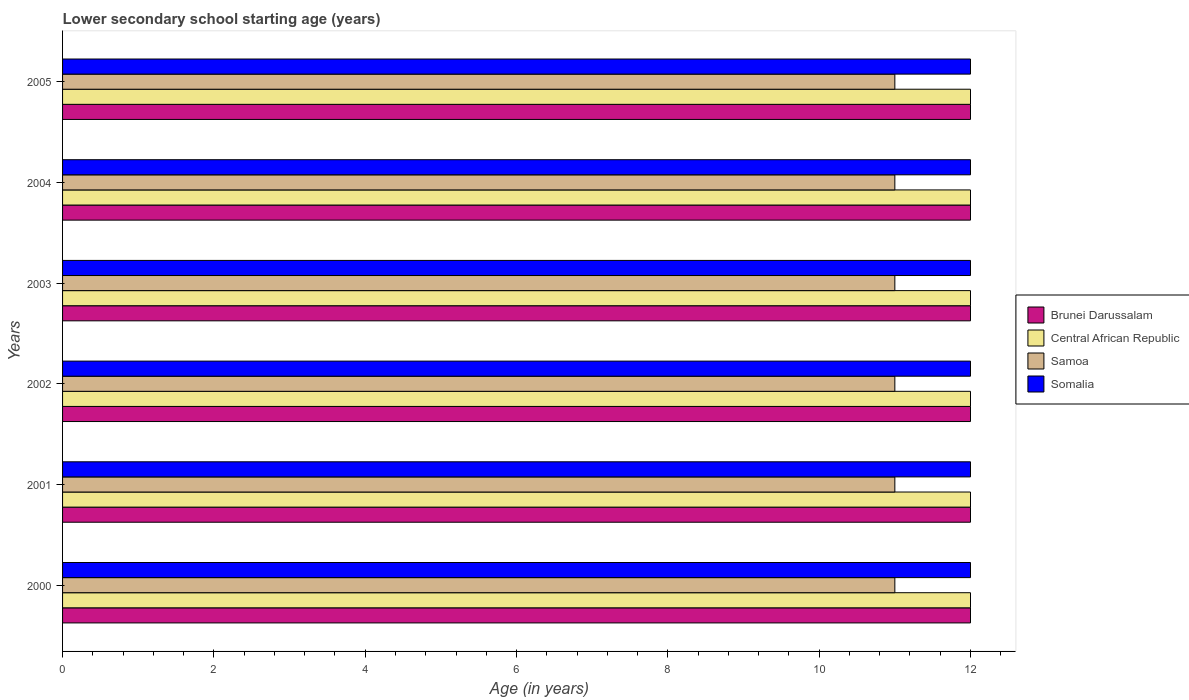How many different coloured bars are there?
Your response must be concise. 4. How many groups of bars are there?
Provide a succinct answer. 6. Are the number of bars per tick equal to the number of legend labels?
Give a very brief answer. Yes. Are the number of bars on each tick of the Y-axis equal?
Offer a very short reply. Yes. How many bars are there on the 1st tick from the top?
Ensure brevity in your answer.  4. How many bars are there on the 4th tick from the bottom?
Make the answer very short. 4. In how many cases, is the number of bars for a given year not equal to the number of legend labels?
Offer a very short reply. 0. What is the lower secondary school starting age of children in Central African Republic in 2005?
Ensure brevity in your answer.  12. Across all years, what is the maximum lower secondary school starting age of children in Samoa?
Offer a terse response. 11. Across all years, what is the minimum lower secondary school starting age of children in Brunei Darussalam?
Make the answer very short. 12. In which year was the lower secondary school starting age of children in Brunei Darussalam minimum?
Your answer should be very brief. 2000. What is the total lower secondary school starting age of children in Somalia in the graph?
Make the answer very short. 72. What is the average lower secondary school starting age of children in Samoa per year?
Make the answer very short. 11. What is the ratio of the lower secondary school starting age of children in Brunei Darussalam in 2002 to that in 2004?
Your response must be concise. 1. Is the difference between the lower secondary school starting age of children in Somalia in 2000 and 2002 greater than the difference between the lower secondary school starting age of children in Brunei Darussalam in 2000 and 2002?
Your response must be concise. No. In how many years, is the lower secondary school starting age of children in Central African Republic greater than the average lower secondary school starting age of children in Central African Republic taken over all years?
Keep it short and to the point. 0. Is the sum of the lower secondary school starting age of children in Somalia in 2003 and 2004 greater than the maximum lower secondary school starting age of children in Samoa across all years?
Offer a terse response. Yes. Is it the case that in every year, the sum of the lower secondary school starting age of children in Brunei Darussalam and lower secondary school starting age of children in Somalia is greater than the sum of lower secondary school starting age of children in Central African Republic and lower secondary school starting age of children in Samoa?
Your answer should be very brief. No. What does the 4th bar from the top in 2001 represents?
Your answer should be compact. Brunei Darussalam. What does the 2nd bar from the bottom in 2003 represents?
Your answer should be compact. Central African Republic. How many bars are there?
Your answer should be compact. 24. Are all the bars in the graph horizontal?
Your answer should be compact. Yes. Are the values on the major ticks of X-axis written in scientific E-notation?
Make the answer very short. No. Does the graph contain grids?
Your answer should be compact. No. Where does the legend appear in the graph?
Provide a short and direct response. Center right. How many legend labels are there?
Make the answer very short. 4. What is the title of the graph?
Ensure brevity in your answer.  Lower secondary school starting age (years). What is the label or title of the X-axis?
Ensure brevity in your answer.  Age (in years). What is the Age (in years) in Central African Republic in 2001?
Ensure brevity in your answer.  12. What is the Age (in years) of Central African Republic in 2002?
Provide a succinct answer. 12. What is the Age (in years) of Somalia in 2002?
Offer a very short reply. 12. What is the Age (in years) of Central African Republic in 2003?
Make the answer very short. 12. What is the Age (in years) of Somalia in 2003?
Provide a succinct answer. 12. What is the Age (in years) in Brunei Darussalam in 2004?
Provide a short and direct response. 12. What is the Age (in years) in Central African Republic in 2004?
Ensure brevity in your answer.  12. What is the Age (in years) in Samoa in 2004?
Your answer should be very brief. 11. What is the Age (in years) of Brunei Darussalam in 2005?
Provide a short and direct response. 12. What is the Age (in years) in Central African Republic in 2005?
Offer a terse response. 12. What is the Age (in years) in Samoa in 2005?
Your answer should be compact. 11. Across all years, what is the maximum Age (in years) in Brunei Darussalam?
Provide a succinct answer. 12. Across all years, what is the minimum Age (in years) of Central African Republic?
Provide a succinct answer. 12. What is the total Age (in years) of Samoa in the graph?
Make the answer very short. 66. What is the total Age (in years) of Somalia in the graph?
Make the answer very short. 72. What is the difference between the Age (in years) of Brunei Darussalam in 2000 and that in 2001?
Offer a terse response. 0. What is the difference between the Age (in years) of Central African Republic in 2000 and that in 2001?
Offer a very short reply. 0. What is the difference between the Age (in years) of Brunei Darussalam in 2000 and that in 2002?
Keep it short and to the point. 0. What is the difference between the Age (in years) of Central African Republic in 2000 and that in 2002?
Offer a terse response. 0. What is the difference between the Age (in years) of Samoa in 2000 and that in 2002?
Provide a short and direct response. 0. What is the difference between the Age (in years) in Brunei Darussalam in 2000 and that in 2003?
Provide a succinct answer. 0. What is the difference between the Age (in years) of Central African Republic in 2000 and that in 2003?
Offer a very short reply. 0. What is the difference between the Age (in years) of Somalia in 2000 and that in 2003?
Your answer should be very brief. 0. What is the difference between the Age (in years) in Brunei Darussalam in 2000 and that in 2004?
Keep it short and to the point. 0. What is the difference between the Age (in years) of Brunei Darussalam in 2000 and that in 2005?
Your response must be concise. 0. What is the difference between the Age (in years) of Samoa in 2000 and that in 2005?
Your answer should be compact. 0. What is the difference between the Age (in years) in Somalia in 2000 and that in 2005?
Ensure brevity in your answer.  0. What is the difference between the Age (in years) in Samoa in 2001 and that in 2002?
Keep it short and to the point. 0. What is the difference between the Age (in years) in Central African Republic in 2001 and that in 2003?
Your answer should be compact. 0. What is the difference between the Age (in years) of Samoa in 2001 and that in 2003?
Provide a succinct answer. 0. What is the difference between the Age (in years) in Somalia in 2001 and that in 2003?
Provide a succinct answer. 0. What is the difference between the Age (in years) in Brunei Darussalam in 2001 and that in 2004?
Your response must be concise. 0. What is the difference between the Age (in years) in Central African Republic in 2001 and that in 2004?
Give a very brief answer. 0. What is the difference between the Age (in years) of Samoa in 2001 and that in 2004?
Offer a very short reply. 0. What is the difference between the Age (in years) in Somalia in 2001 and that in 2004?
Your answer should be compact. 0. What is the difference between the Age (in years) of Central African Republic in 2001 and that in 2005?
Provide a short and direct response. 0. What is the difference between the Age (in years) of Samoa in 2001 and that in 2005?
Keep it short and to the point. 0. What is the difference between the Age (in years) in Somalia in 2001 and that in 2005?
Provide a short and direct response. 0. What is the difference between the Age (in years) of Brunei Darussalam in 2002 and that in 2003?
Your answer should be very brief. 0. What is the difference between the Age (in years) in Samoa in 2002 and that in 2004?
Your answer should be very brief. 0. What is the difference between the Age (in years) of Somalia in 2002 and that in 2004?
Provide a succinct answer. 0. What is the difference between the Age (in years) of Brunei Darussalam in 2002 and that in 2005?
Provide a short and direct response. 0. What is the difference between the Age (in years) of Central African Republic in 2002 and that in 2005?
Provide a succinct answer. 0. What is the difference between the Age (in years) in Somalia in 2002 and that in 2005?
Keep it short and to the point. 0. What is the difference between the Age (in years) of Central African Republic in 2003 and that in 2004?
Ensure brevity in your answer.  0. What is the difference between the Age (in years) in Samoa in 2003 and that in 2004?
Give a very brief answer. 0. What is the difference between the Age (in years) in Somalia in 2003 and that in 2004?
Give a very brief answer. 0. What is the difference between the Age (in years) in Brunei Darussalam in 2003 and that in 2005?
Provide a short and direct response. 0. What is the difference between the Age (in years) in Somalia in 2003 and that in 2005?
Offer a very short reply. 0. What is the difference between the Age (in years) in Brunei Darussalam in 2004 and that in 2005?
Make the answer very short. 0. What is the difference between the Age (in years) in Somalia in 2004 and that in 2005?
Provide a succinct answer. 0. What is the difference between the Age (in years) in Brunei Darussalam in 2000 and the Age (in years) in Central African Republic in 2001?
Your answer should be compact. 0. What is the difference between the Age (in years) of Brunei Darussalam in 2000 and the Age (in years) of Somalia in 2001?
Keep it short and to the point. 0. What is the difference between the Age (in years) in Central African Republic in 2000 and the Age (in years) in Samoa in 2001?
Keep it short and to the point. 1. What is the difference between the Age (in years) of Brunei Darussalam in 2000 and the Age (in years) of Somalia in 2002?
Ensure brevity in your answer.  0. What is the difference between the Age (in years) in Central African Republic in 2000 and the Age (in years) in Somalia in 2002?
Your answer should be compact. 0. What is the difference between the Age (in years) of Samoa in 2000 and the Age (in years) of Somalia in 2002?
Your response must be concise. -1. What is the difference between the Age (in years) of Brunei Darussalam in 2000 and the Age (in years) of Samoa in 2003?
Provide a succinct answer. 1. What is the difference between the Age (in years) in Brunei Darussalam in 2000 and the Age (in years) in Somalia in 2003?
Provide a succinct answer. 0. What is the difference between the Age (in years) in Central African Republic in 2000 and the Age (in years) in Samoa in 2003?
Give a very brief answer. 1. What is the difference between the Age (in years) in Samoa in 2000 and the Age (in years) in Somalia in 2003?
Your answer should be very brief. -1. What is the difference between the Age (in years) in Brunei Darussalam in 2000 and the Age (in years) in Central African Republic in 2004?
Keep it short and to the point. 0. What is the difference between the Age (in years) in Brunei Darussalam in 2000 and the Age (in years) in Samoa in 2004?
Provide a short and direct response. 1. What is the difference between the Age (in years) in Brunei Darussalam in 2000 and the Age (in years) in Somalia in 2004?
Your answer should be compact. 0. What is the difference between the Age (in years) in Central African Republic in 2000 and the Age (in years) in Samoa in 2004?
Offer a very short reply. 1. What is the difference between the Age (in years) of Central African Republic in 2000 and the Age (in years) of Somalia in 2004?
Give a very brief answer. 0. What is the difference between the Age (in years) in Brunei Darussalam in 2000 and the Age (in years) in Central African Republic in 2005?
Ensure brevity in your answer.  0. What is the difference between the Age (in years) in Brunei Darussalam in 2000 and the Age (in years) in Somalia in 2005?
Your answer should be compact. 0. What is the difference between the Age (in years) of Central African Republic in 2000 and the Age (in years) of Somalia in 2005?
Ensure brevity in your answer.  0. What is the difference between the Age (in years) in Samoa in 2000 and the Age (in years) in Somalia in 2005?
Provide a succinct answer. -1. What is the difference between the Age (in years) of Brunei Darussalam in 2001 and the Age (in years) of Central African Republic in 2002?
Offer a very short reply. 0. What is the difference between the Age (in years) in Brunei Darussalam in 2001 and the Age (in years) in Samoa in 2002?
Your answer should be very brief. 1. What is the difference between the Age (in years) of Brunei Darussalam in 2001 and the Age (in years) of Somalia in 2002?
Provide a succinct answer. 0. What is the difference between the Age (in years) of Central African Republic in 2001 and the Age (in years) of Samoa in 2002?
Ensure brevity in your answer.  1. What is the difference between the Age (in years) in Samoa in 2001 and the Age (in years) in Somalia in 2002?
Provide a short and direct response. -1. What is the difference between the Age (in years) of Brunei Darussalam in 2001 and the Age (in years) of Central African Republic in 2003?
Your answer should be very brief. 0. What is the difference between the Age (in years) of Brunei Darussalam in 2001 and the Age (in years) of Somalia in 2004?
Give a very brief answer. 0. What is the difference between the Age (in years) of Central African Republic in 2001 and the Age (in years) of Samoa in 2004?
Keep it short and to the point. 1. What is the difference between the Age (in years) of Central African Republic in 2001 and the Age (in years) of Somalia in 2004?
Make the answer very short. 0. What is the difference between the Age (in years) in Brunei Darussalam in 2001 and the Age (in years) in Somalia in 2005?
Provide a short and direct response. 0. What is the difference between the Age (in years) in Central African Republic in 2001 and the Age (in years) in Samoa in 2005?
Ensure brevity in your answer.  1. What is the difference between the Age (in years) in Central African Republic in 2001 and the Age (in years) in Somalia in 2005?
Offer a terse response. 0. What is the difference between the Age (in years) of Central African Republic in 2002 and the Age (in years) of Samoa in 2003?
Give a very brief answer. 1. What is the difference between the Age (in years) of Samoa in 2002 and the Age (in years) of Somalia in 2003?
Make the answer very short. -1. What is the difference between the Age (in years) in Brunei Darussalam in 2002 and the Age (in years) in Somalia in 2004?
Provide a succinct answer. 0. What is the difference between the Age (in years) of Brunei Darussalam in 2002 and the Age (in years) of Samoa in 2005?
Ensure brevity in your answer.  1. What is the difference between the Age (in years) in Brunei Darussalam in 2002 and the Age (in years) in Somalia in 2005?
Your response must be concise. 0. What is the difference between the Age (in years) in Samoa in 2002 and the Age (in years) in Somalia in 2005?
Your response must be concise. -1. What is the difference between the Age (in years) of Brunei Darussalam in 2003 and the Age (in years) of Samoa in 2004?
Your answer should be compact. 1. What is the difference between the Age (in years) in Central African Republic in 2003 and the Age (in years) in Samoa in 2004?
Make the answer very short. 1. What is the difference between the Age (in years) of Central African Republic in 2003 and the Age (in years) of Somalia in 2004?
Your answer should be very brief. 0. What is the difference between the Age (in years) in Samoa in 2003 and the Age (in years) in Somalia in 2004?
Offer a terse response. -1. What is the difference between the Age (in years) in Brunei Darussalam in 2003 and the Age (in years) in Central African Republic in 2005?
Provide a succinct answer. 0. What is the difference between the Age (in years) in Brunei Darussalam in 2003 and the Age (in years) in Somalia in 2005?
Keep it short and to the point. 0. What is the difference between the Age (in years) of Central African Republic in 2003 and the Age (in years) of Somalia in 2005?
Make the answer very short. 0. What is the difference between the Age (in years) in Brunei Darussalam in 2004 and the Age (in years) in Central African Republic in 2005?
Keep it short and to the point. 0. What is the difference between the Age (in years) of Brunei Darussalam in 2004 and the Age (in years) of Somalia in 2005?
Give a very brief answer. 0. What is the difference between the Age (in years) of Central African Republic in 2004 and the Age (in years) of Samoa in 2005?
Your answer should be very brief. 1. What is the average Age (in years) of Brunei Darussalam per year?
Make the answer very short. 12. What is the average Age (in years) in Somalia per year?
Your response must be concise. 12. In the year 2000, what is the difference between the Age (in years) in Brunei Darussalam and Age (in years) in Central African Republic?
Ensure brevity in your answer.  0. In the year 2000, what is the difference between the Age (in years) in Brunei Darussalam and Age (in years) in Somalia?
Your response must be concise. 0. In the year 2000, what is the difference between the Age (in years) of Central African Republic and Age (in years) of Samoa?
Provide a short and direct response. 1. In the year 2000, what is the difference between the Age (in years) of Samoa and Age (in years) of Somalia?
Offer a very short reply. -1. In the year 2001, what is the difference between the Age (in years) in Brunei Darussalam and Age (in years) in Central African Republic?
Provide a short and direct response. 0. In the year 2001, what is the difference between the Age (in years) of Brunei Darussalam and Age (in years) of Samoa?
Your answer should be very brief. 1. In the year 2001, what is the difference between the Age (in years) in Brunei Darussalam and Age (in years) in Somalia?
Offer a terse response. 0. In the year 2001, what is the difference between the Age (in years) of Central African Republic and Age (in years) of Samoa?
Provide a succinct answer. 1. In the year 2001, what is the difference between the Age (in years) of Central African Republic and Age (in years) of Somalia?
Your answer should be compact. 0. In the year 2002, what is the difference between the Age (in years) of Brunei Darussalam and Age (in years) of Central African Republic?
Your answer should be compact. 0. In the year 2002, what is the difference between the Age (in years) in Brunei Darussalam and Age (in years) in Samoa?
Your answer should be very brief. 1. In the year 2003, what is the difference between the Age (in years) in Brunei Darussalam and Age (in years) in Central African Republic?
Your response must be concise. 0. In the year 2003, what is the difference between the Age (in years) in Brunei Darussalam and Age (in years) in Samoa?
Give a very brief answer. 1. In the year 2003, what is the difference between the Age (in years) in Brunei Darussalam and Age (in years) in Somalia?
Your response must be concise. 0. In the year 2003, what is the difference between the Age (in years) of Central African Republic and Age (in years) of Samoa?
Your answer should be compact. 1. In the year 2003, what is the difference between the Age (in years) in Central African Republic and Age (in years) in Somalia?
Ensure brevity in your answer.  0. In the year 2003, what is the difference between the Age (in years) of Samoa and Age (in years) of Somalia?
Give a very brief answer. -1. In the year 2004, what is the difference between the Age (in years) of Brunei Darussalam and Age (in years) of Central African Republic?
Make the answer very short. 0. In the year 2004, what is the difference between the Age (in years) in Brunei Darussalam and Age (in years) in Somalia?
Your response must be concise. 0. In the year 2004, what is the difference between the Age (in years) of Central African Republic and Age (in years) of Samoa?
Keep it short and to the point. 1. In the year 2004, what is the difference between the Age (in years) of Central African Republic and Age (in years) of Somalia?
Keep it short and to the point. 0. In the year 2004, what is the difference between the Age (in years) of Samoa and Age (in years) of Somalia?
Your answer should be very brief. -1. In the year 2005, what is the difference between the Age (in years) of Brunei Darussalam and Age (in years) of Central African Republic?
Make the answer very short. 0. In the year 2005, what is the difference between the Age (in years) in Brunei Darussalam and Age (in years) in Somalia?
Give a very brief answer. 0. In the year 2005, what is the difference between the Age (in years) in Central African Republic and Age (in years) in Somalia?
Ensure brevity in your answer.  0. In the year 2005, what is the difference between the Age (in years) in Samoa and Age (in years) in Somalia?
Make the answer very short. -1. What is the ratio of the Age (in years) in Brunei Darussalam in 2000 to that in 2001?
Keep it short and to the point. 1. What is the ratio of the Age (in years) of Central African Republic in 2000 to that in 2001?
Provide a short and direct response. 1. What is the ratio of the Age (in years) of Somalia in 2000 to that in 2001?
Keep it short and to the point. 1. What is the ratio of the Age (in years) in Central African Republic in 2000 to that in 2002?
Provide a succinct answer. 1. What is the ratio of the Age (in years) in Samoa in 2000 to that in 2002?
Your answer should be compact. 1. What is the ratio of the Age (in years) in Somalia in 2000 to that in 2002?
Ensure brevity in your answer.  1. What is the ratio of the Age (in years) in Brunei Darussalam in 2000 to that in 2003?
Offer a terse response. 1. What is the ratio of the Age (in years) of Somalia in 2000 to that in 2003?
Offer a very short reply. 1. What is the ratio of the Age (in years) in Samoa in 2000 to that in 2004?
Provide a short and direct response. 1. What is the ratio of the Age (in years) in Brunei Darussalam in 2000 to that in 2005?
Ensure brevity in your answer.  1. What is the ratio of the Age (in years) in Central African Republic in 2000 to that in 2005?
Offer a terse response. 1. What is the ratio of the Age (in years) in Samoa in 2000 to that in 2005?
Offer a terse response. 1. What is the ratio of the Age (in years) in Somalia in 2000 to that in 2005?
Keep it short and to the point. 1. What is the ratio of the Age (in years) in Brunei Darussalam in 2001 to that in 2002?
Ensure brevity in your answer.  1. What is the ratio of the Age (in years) of Central African Republic in 2001 to that in 2002?
Keep it short and to the point. 1. What is the ratio of the Age (in years) of Brunei Darussalam in 2001 to that in 2003?
Provide a succinct answer. 1. What is the ratio of the Age (in years) in Samoa in 2001 to that in 2003?
Offer a very short reply. 1. What is the ratio of the Age (in years) in Central African Republic in 2001 to that in 2004?
Make the answer very short. 1. What is the ratio of the Age (in years) in Central African Republic in 2002 to that in 2003?
Offer a terse response. 1. What is the ratio of the Age (in years) of Samoa in 2002 to that in 2003?
Give a very brief answer. 1. What is the ratio of the Age (in years) of Brunei Darussalam in 2002 to that in 2004?
Provide a short and direct response. 1. What is the ratio of the Age (in years) in Central African Republic in 2002 to that in 2005?
Offer a very short reply. 1. What is the ratio of the Age (in years) in Samoa in 2002 to that in 2005?
Offer a terse response. 1. What is the ratio of the Age (in years) in Brunei Darussalam in 2003 to that in 2004?
Your answer should be compact. 1. What is the ratio of the Age (in years) in Central African Republic in 2003 to that in 2004?
Provide a short and direct response. 1. What is the ratio of the Age (in years) in Somalia in 2003 to that in 2004?
Your response must be concise. 1. What is the ratio of the Age (in years) of Brunei Darussalam in 2003 to that in 2005?
Offer a terse response. 1. What is the ratio of the Age (in years) in Somalia in 2003 to that in 2005?
Your response must be concise. 1. What is the ratio of the Age (in years) in Brunei Darussalam in 2004 to that in 2005?
Your answer should be compact. 1. What is the ratio of the Age (in years) of Somalia in 2004 to that in 2005?
Offer a terse response. 1. What is the difference between the highest and the second highest Age (in years) of Brunei Darussalam?
Your answer should be compact. 0. What is the difference between the highest and the second highest Age (in years) in Central African Republic?
Offer a terse response. 0. What is the difference between the highest and the second highest Age (in years) of Samoa?
Your response must be concise. 0. What is the difference between the highest and the lowest Age (in years) of Brunei Darussalam?
Ensure brevity in your answer.  0. What is the difference between the highest and the lowest Age (in years) of Samoa?
Offer a terse response. 0. What is the difference between the highest and the lowest Age (in years) in Somalia?
Ensure brevity in your answer.  0. 